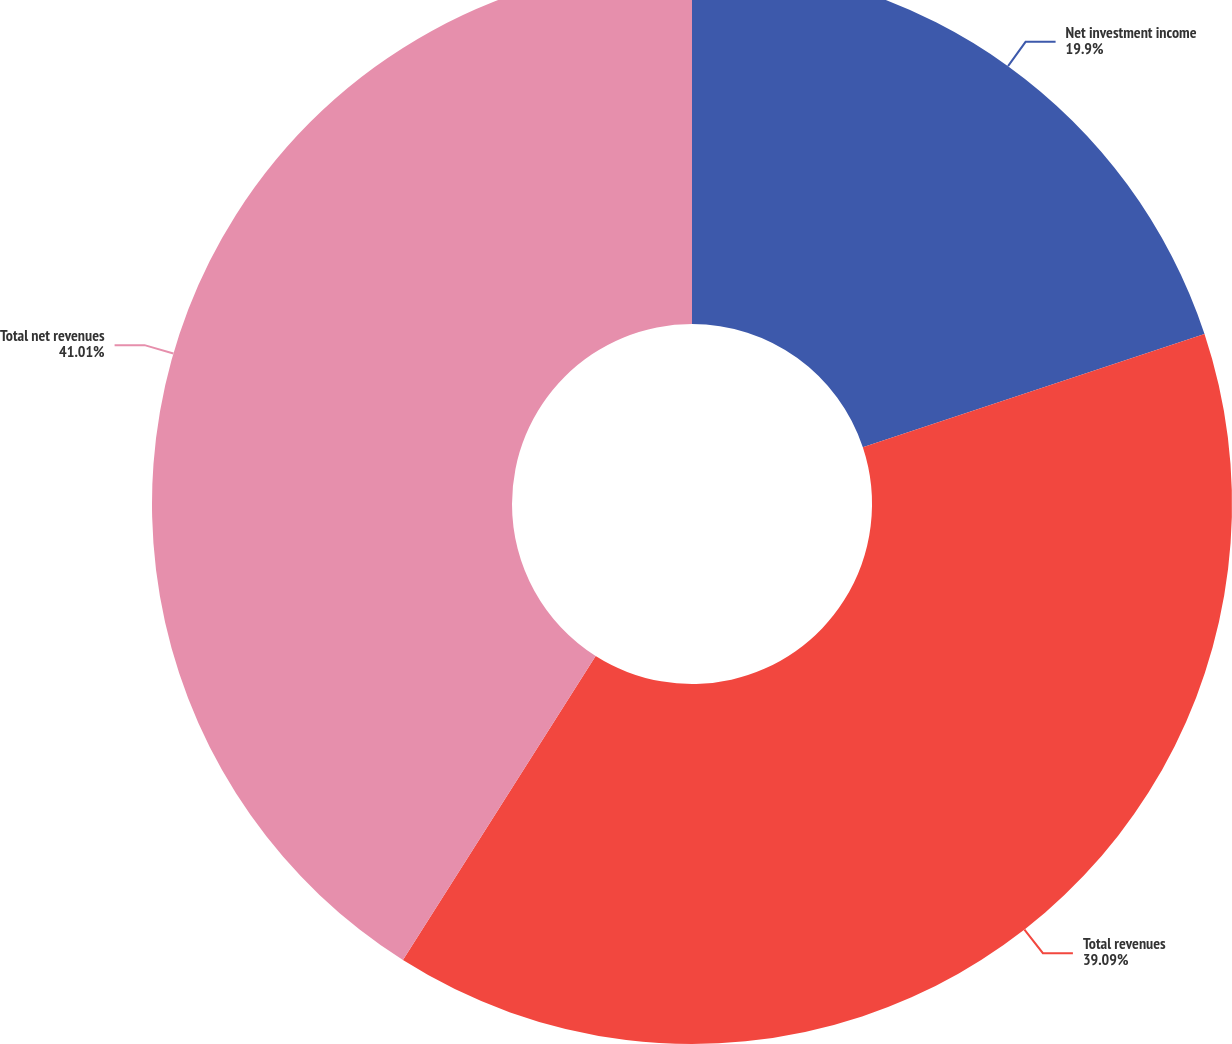Convert chart. <chart><loc_0><loc_0><loc_500><loc_500><pie_chart><fcel>Net investment income<fcel>Total revenues<fcel>Total net revenues<nl><fcel>19.9%<fcel>39.09%<fcel>41.01%<nl></chart> 